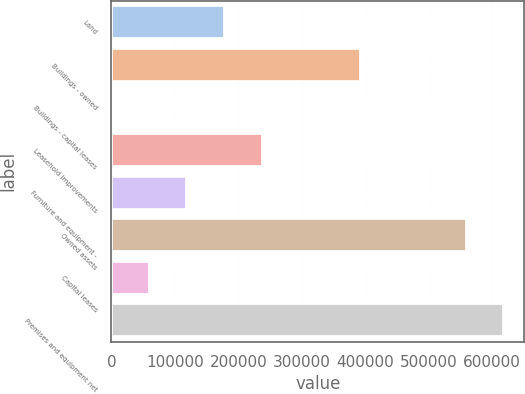Convert chart. <chart><loc_0><loc_0><loc_500><loc_500><bar_chart><fcel>Land<fcel>Buildings - owned<fcel>Buildings - capital leases<fcel>Leasehold improvements<fcel>Furniture and equipment -<fcel>Owned assets<fcel>Capital leases<fcel>Premises and equipment net<nl><fcel>179187<fcel>393527<fcel>1131<fcel>238539<fcel>119835<fcel>559948<fcel>60483.1<fcel>619300<nl></chart> 